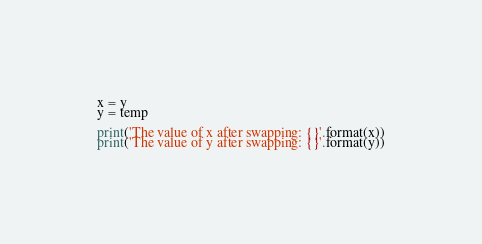Convert code to text. <code><loc_0><loc_0><loc_500><loc_500><_Python_>x = y
y = temp

print('The value of x after swapping: {}'.format(x))
print('The value of y after swapping: {}'.format(y))
</code> 